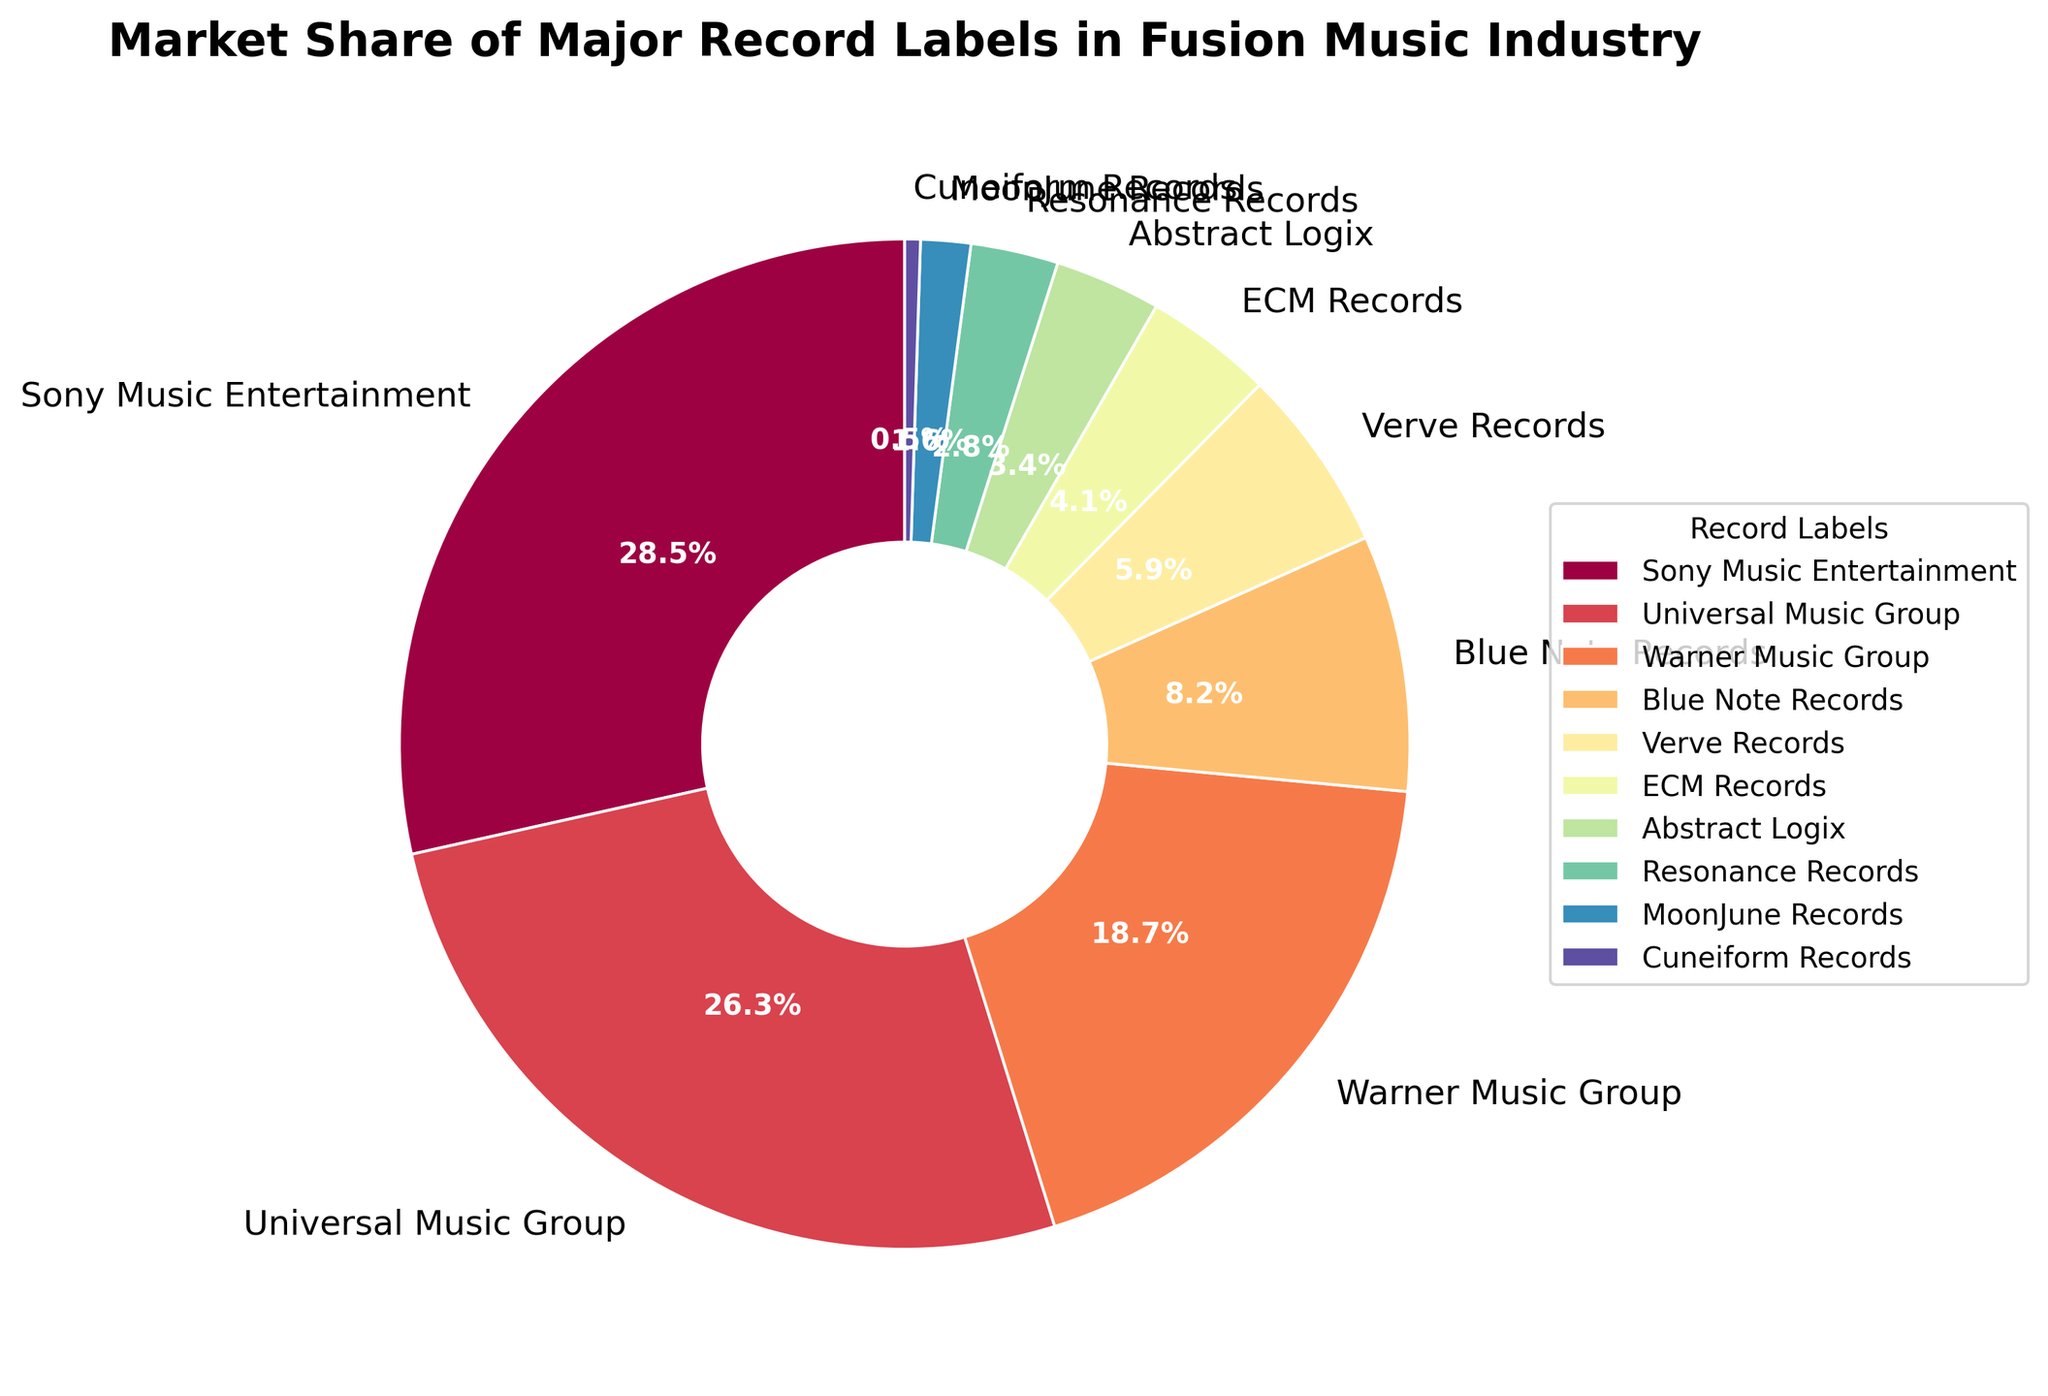What's the overall market share of Blue Note Records and Verve Records combined? To find the combined market share, sum the individual market shares of Blue Note Records and Verve Records: 8.2% + 5.9% = 14.1%
Answer: 14.1% Which record label has the smallest market share, and what is its percentage? Identify the label with the smallest percentage, which is Cuneiform Records at 0.5%.
Answer: Cuneiform Records, 0.5% How many record labels have a market share greater than 20%? Look at the labels with market shares greater than 20%: Sony Music Entertainment (28.5%) and Universal Music Group (26.3%). There are 2 such labels.
Answer: 2 Is the market share of Abstract Logix greater or less than half of Warner Music Group's market share? Half of Warner Music Group's market share is 18.7% / 2 = 9.35%. Abstract Logix's market share is 3.4%, which is less than 9.35%.
Answer: Less What is the difference in market share between Sony Music Entertainment and Universal Music Group? Subtract the market share of Universal Music Group from Sony Music Entertainment's: 28.5% - 26.3% = 2.2%.
Answer: 2.2% What is the average market share of the three labels with the smallest market shares? Find the three smallest market shares: Cuneiform Records (0.5%), MoonJune Records (1.6%), and Resonance Records (2.8%). Calculate the average: (0.5 + 1.6 + 2.8) / 3 = 1.63%.
Answer: 1.63% Which record label segment appears with a pinkish color in the pie chart? The custom color palette and corresponding order from data typically associate the third or fourth segment with a pinkish color. Based on provided labels, it would be Warner Music Group.
Answer: Warner Music Group How much more market share does Universal Music Group hold compared to both ECM Records and Abstract Logix combined? Sum the market shares of ECM Records (4.1%) and Abstract Logix (3.4%) to get 7.5%. Subtract this from Universal Music Group's market share: 26.3% - 7.5% = 18.8%.
Answer: 18.8% Which label has a market share closest to 5%? Compare each label's market share to 5%. Verve Records at 5.9% is the closest.
Answer: Verve Records What proportion of the total market share is held by the top three record labels? Sum the market shares of Sony Music Entertainment (28.5%), Universal Music Group (26.3%), and Warner Music Group (18.7%). Their combined share is 28.5% + 26.3% + 18.7% = 73.5%.
Answer: 73.5% 